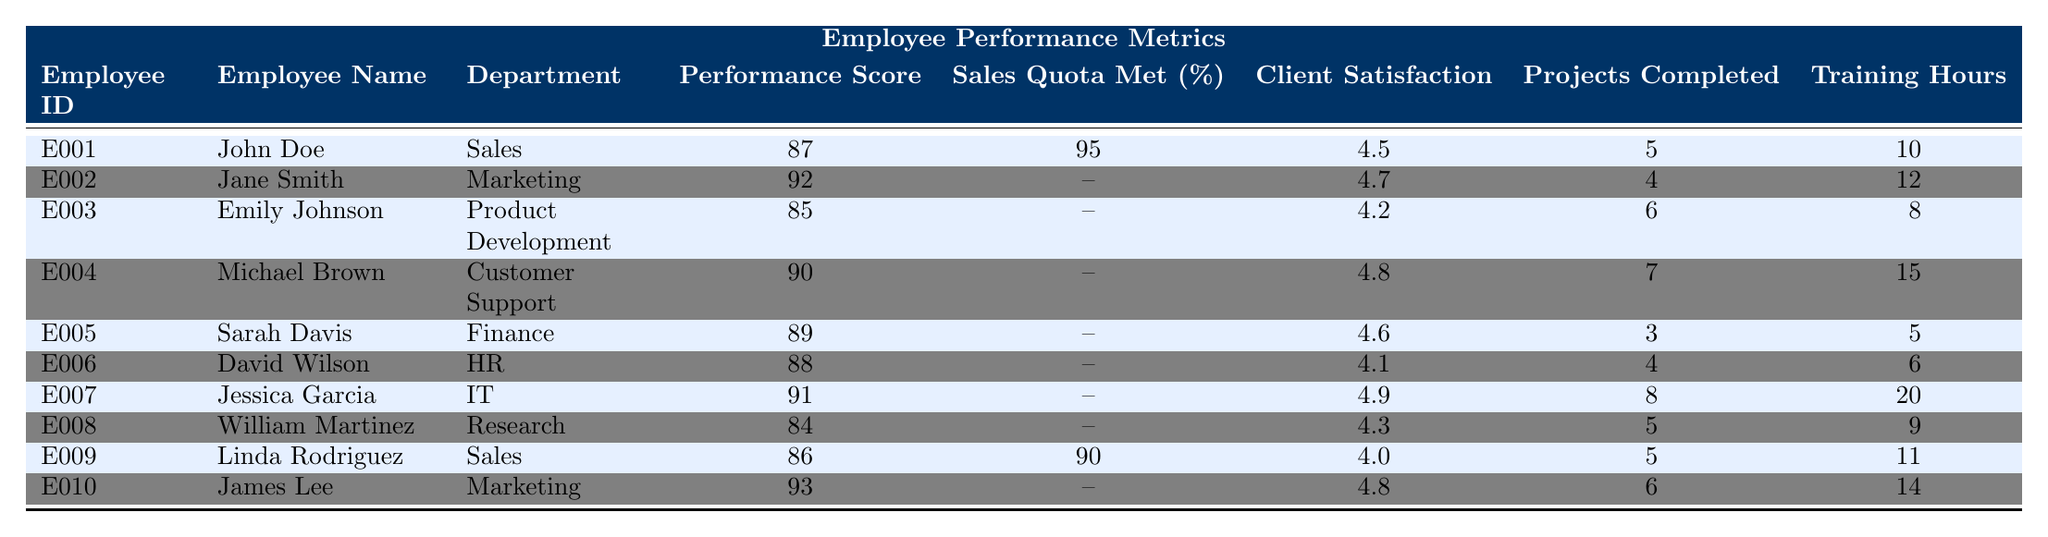What is the highest Performance Score among the employees? The highest Performance Score in the table is 93, which belongs to James Lee in the Marketing department.
Answer: 93 What is the average Client Satisfaction Rating across all employees? To find the average Client Satisfaction Rating, we sum all the ratings: (4.5 + 4.7 + 4.2 + 4.8 + 4.6 + 4.1 + 4.9 + 4.3 + 4.0 + 4.8) = 46.9. There are 10 employees, so the average is 46.9 / 10 = 4.69.
Answer: 4.69 How many employees completed more than 5 projects? Looking at the Projects Completed column, we see that Michael Brown, Jessica Garcia, and Emily Johnson completed more than 5 projects (7, 8, and 6 respectively). Thus, there are 3 employees who completed more than 5 projects.
Answer: 3 Which department has the lowest Performance Score? The lowest Performance Score is 84, which belongs to William Martinez in the Research department.
Answer: Research Is there any employee who met their Sales Quota? Yes, John Doe and Linda Rodriguez met their Sales Quota, scoring 95% and 90% respectively.
Answer: Yes What is the difference in Training Hours between the employee with the most and the least Training Hours? The employee with the most Training Hours is Jessica Garcia with 20 hours, and the least is Sarah Davis with 5 hours. The difference is 20 - 5 = 15 hours.
Answer: 15 How many departments have a Performance Score above 89? The departments with a Performance Score above 89 are Marketing (Jane Smith and James Lee) and IT (Jessica Garcia). There are 3 employees: James Lee (93), Jane Smith (92), and Jessica Garcia (91), indicating 3 departments with employees above 89.
Answer: 3 Is the Client Satisfaction Rating for John Doe higher or lower than the average Client Satisfaction Rating? John Doe has a rating of 4.5, which is lower than the average Client Satisfaction Rating of 4.69.
Answer: Lower Which employee has the highest Client Satisfaction Rating? The highest Client Satisfaction Rating of 4.9 belongs to Jessica Garcia in the IT department.
Answer: Jessica Garcia What percentage of employees met their Sales Quota? Out of 10 employees, 2 met their Sales Quota: John Doe and Linda Rodriguez, giving a percentage of (2/10) * 100 = 20%.
Answer: 20% 